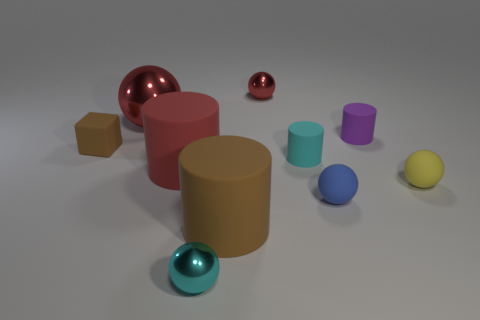What size is the matte cylinder that is the same color as the tiny cube?
Ensure brevity in your answer.  Large. There is a big cylinder that is to the right of the red rubber cylinder; does it have the same color as the block?
Give a very brief answer. Yes. The red rubber object that is the same shape as the purple thing is what size?
Ensure brevity in your answer.  Large. There is a matte cylinder that is on the right side of the cyan matte cylinder; is it the same size as the large red shiny ball?
Your response must be concise. No. What is the material of the brown cylinder?
Give a very brief answer. Rubber. There is a cylinder that is both to the left of the small cyan cylinder and on the right side of the red rubber thing; what is its material?
Provide a succinct answer. Rubber. What number of objects are large red objects that are to the right of the large red metallic ball or small yellow rubber cubes?
Your answer should be very brief. 1. Are there any blue spheres that have the same size as the purple matte object?
Provide a succinct answer. Yes. What number of matte things are both behind the yellow sphere and to the right of the small red ball?
Provide a short and direct response. 2. How many large brown matte cylinders are behind the small purple object?
Ensure brevity in your answer.  0. 